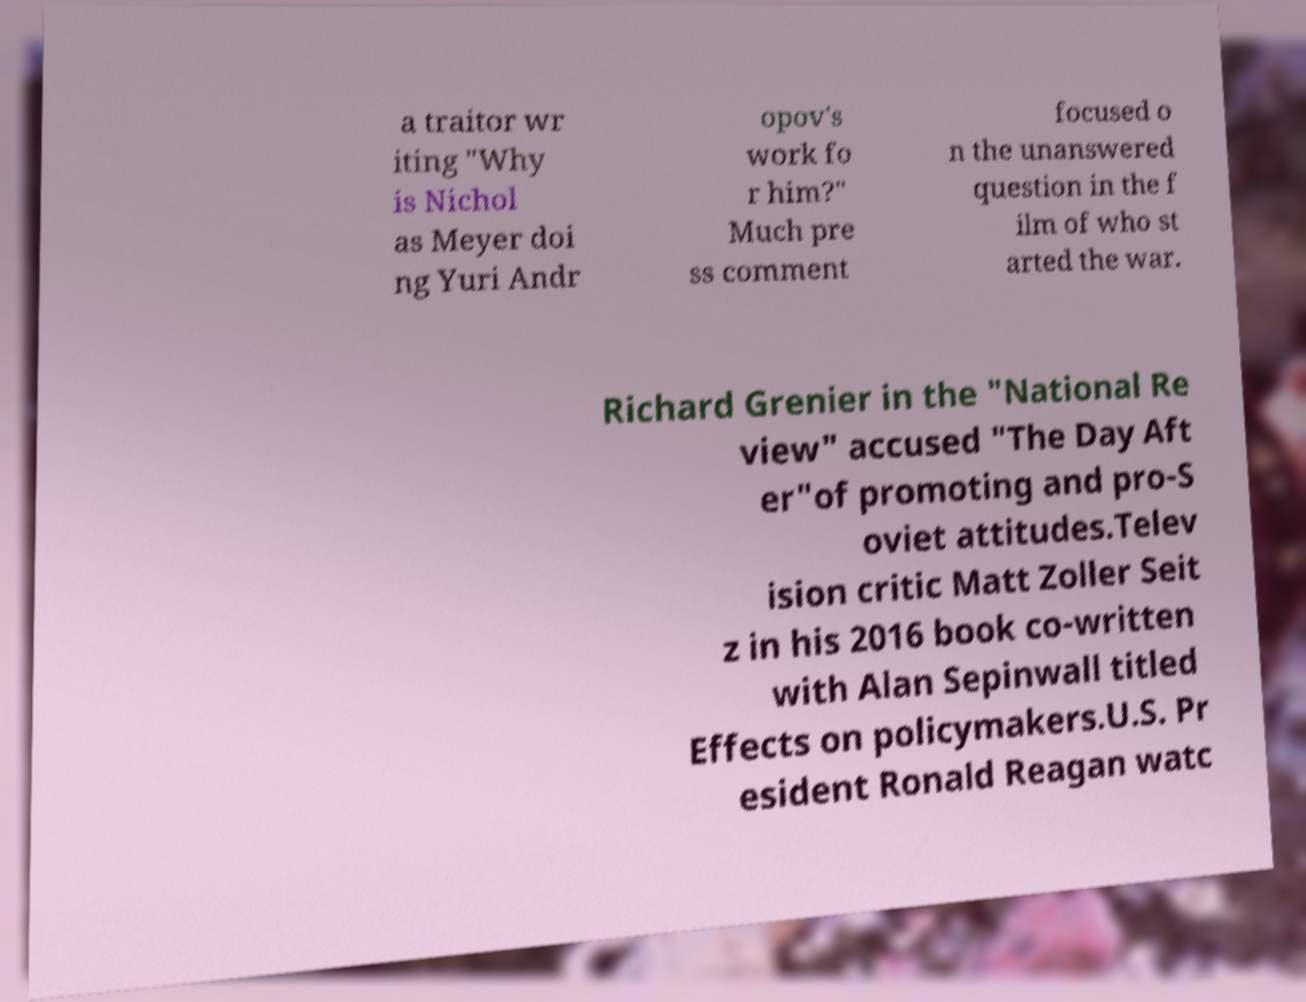Could you extract and type out the text from this image? a traitor wr iting "Why is Nichol as Meyer doi ng Yuri Andr opov's work fo r him?" Much pre ss comment focused o n the unanswered question in the f ilm of who st arted the war. Richard Grenier in the "National Re view" accused "The Day Aft er"of promoting and pro-S oviet attitudes.Telev ision critic Matt Zoller Seit z in his 2016 book co-written with Alan Sepinwall titled Effects on policymakers.U.S. Pr esident Ronald Reagan watc 